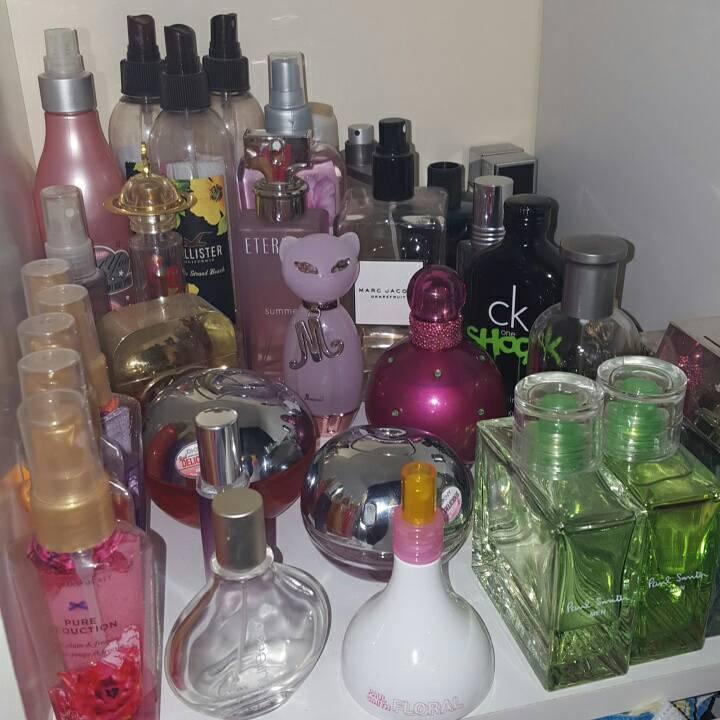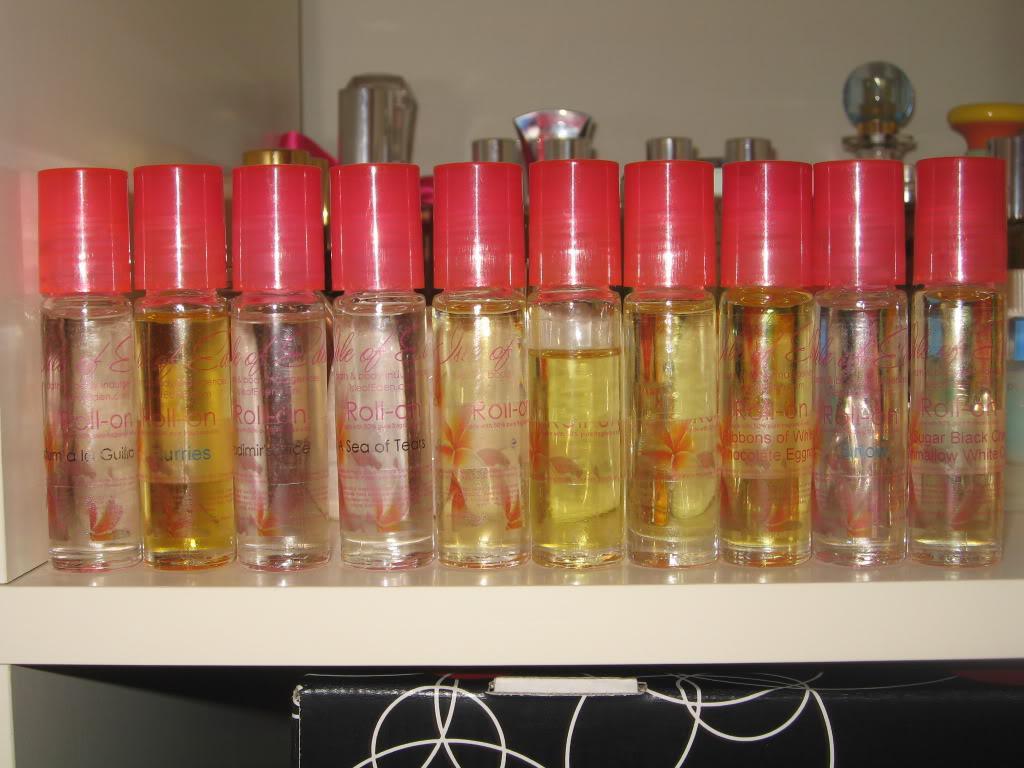The first image is the image on the left, the second image is the image on the right. For the images shown, is this caption "Two of the perfume bottles are squat and round with rounded, reflective chrome tops." true? Answer yes or no. Yes. The first image is the image on the left, the second image is the image on the right. Evaluate the accuracy of this statement regarding the images: "There are at least 10 perfume bottles with the same color and style top.". Is it true? Answer yes or no. Yes. 